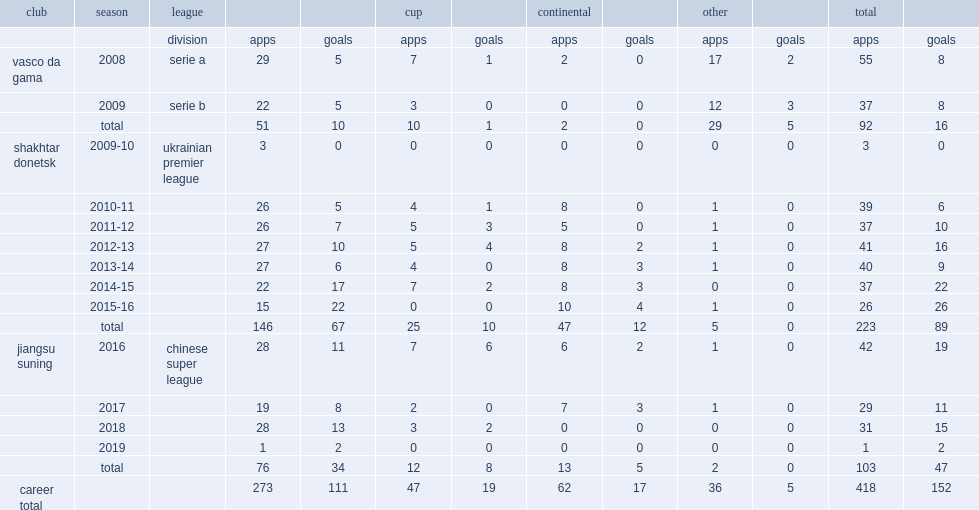In 2016, which league was alex teixeira with chinese super league side jiangsu suning? Chinese super league. 